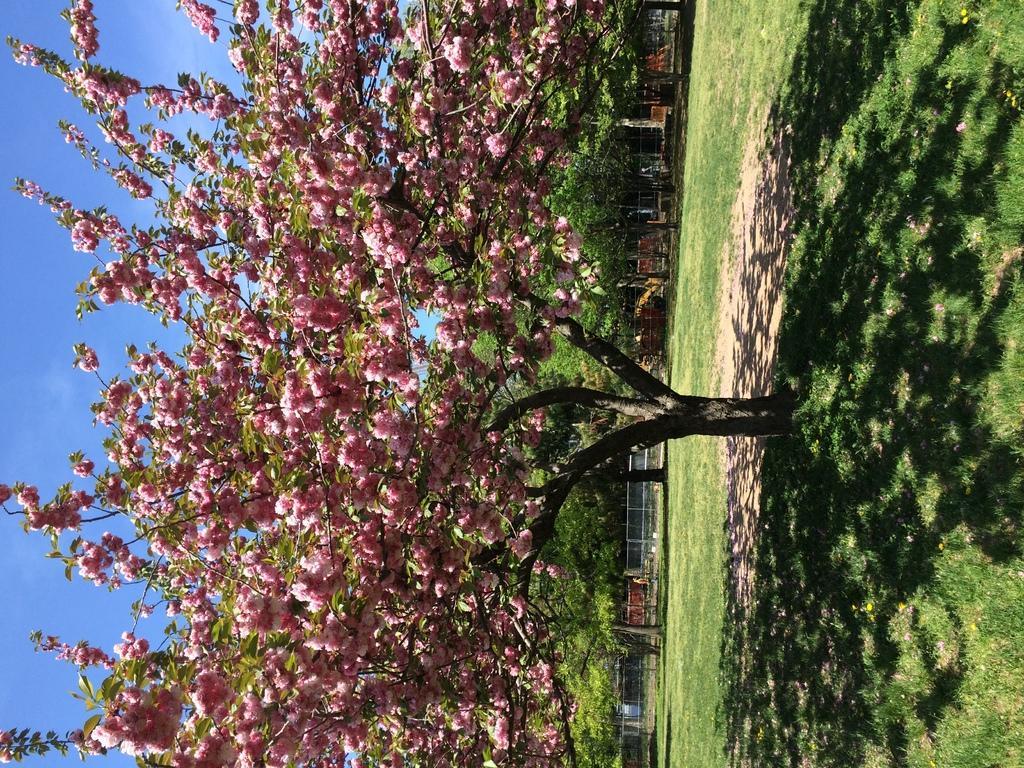Describe this image in one or two sentences. On the right side, there is a tree having pink color flowers on the ground, on which there is grass. In the background, there are trees, a fence and there are clouds in the blue sky. 